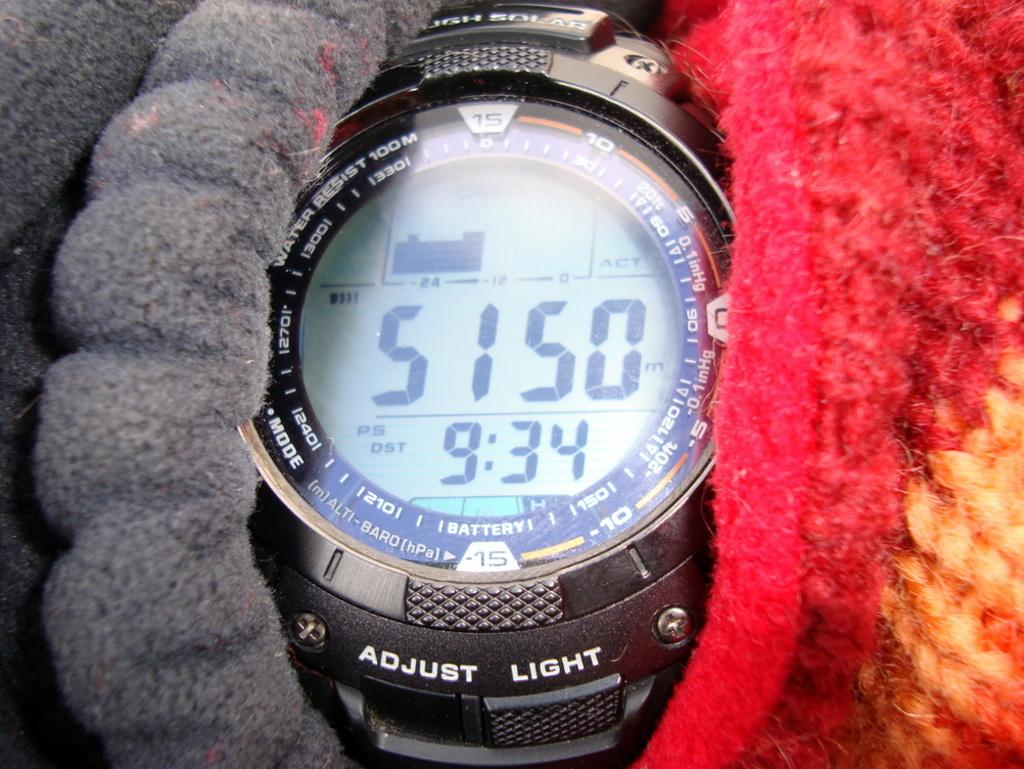<image>
Share a concise interpretation of the image provided. someone is wearing a watch with 5150m and 9:34 displayed on it 